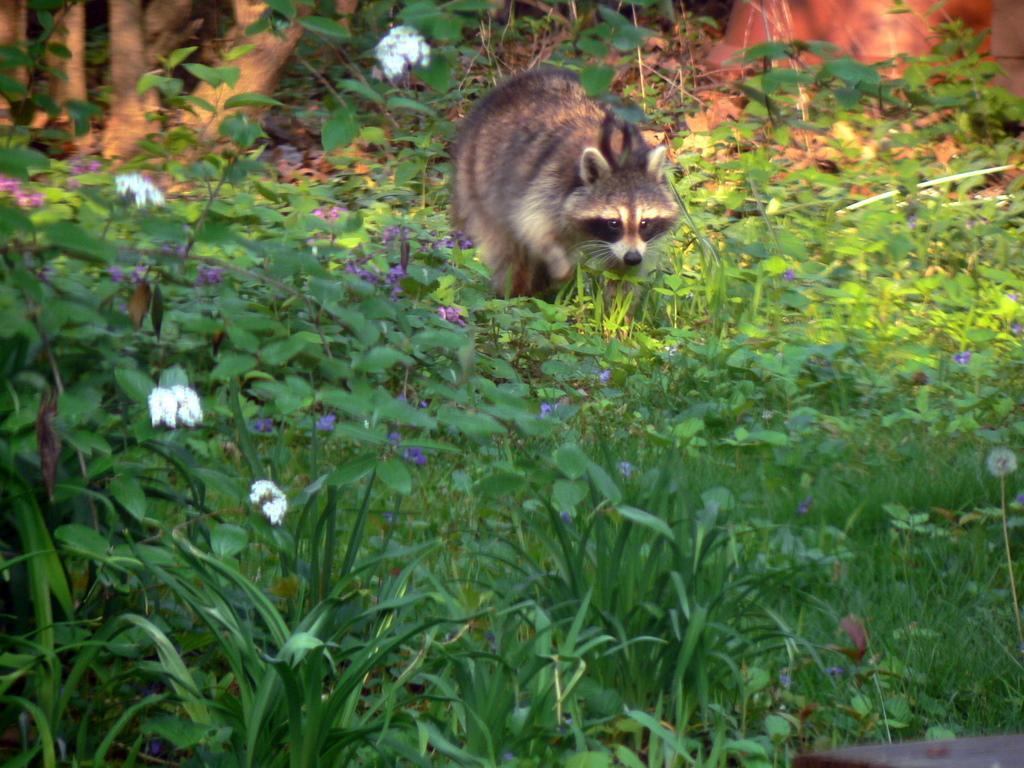Can you describe this image briefly? In this image I can see flowering plants, an animal on grass and tree trunks. This image is taken may be in the forest. 